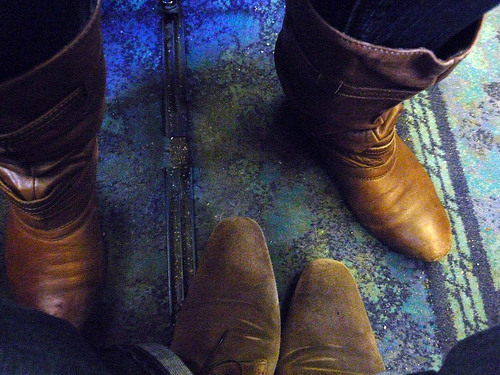<image>
Is there a boot in front of the boot? No. The boot is not in front of the boot. The spatial positioning shows a different relationship between these objects. 